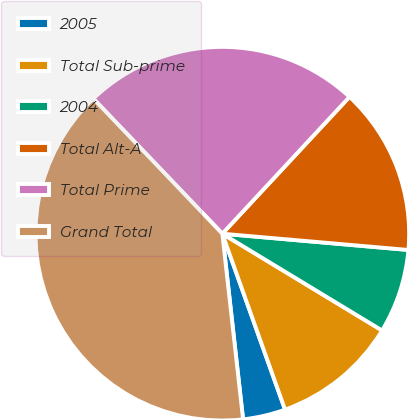Convert chart to OTSL. <chart><loc_0><loc_0><loc_500><loc_500><pie_chart><fcel>2005<fcel>Total Sub-prime<fcel>2004<fcel>Total Alt-A<fcel>Total Prime<fcel>Grand Total<nl><fcel>3.68%<fcel>10.88%<fcel>7.28%<fcel>14.47%<fcel>24.05%<fcel>39.64%<nl></chart> 